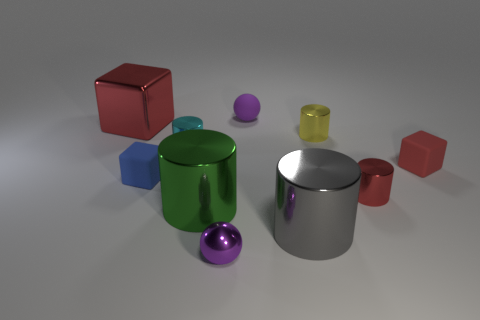What shape is the shiny thing that is the same color as the small matte ball?
Your answer should be compact. Sphere. How many metallic objects are either small purple spheres or big cyan spheres?
Give a very brief answer. 1. There is a big metal object that is behind the small metal cylinder on the left side of the green shiny cylinder; what is its shape?
Your response must be concise. Cube. Is the number of small cyan metallic objects that are on the right side of the big green object less than the number of large red blocks?
Ensure brevity in your answer.  Yes. The red matte thing has what shape?
Give a very brief answer. Cube. There is a red object left of the small purple metal object; how big is it?
Ensure brevity in your answer.  Large. What is the color of the shiny cube that is the same size as the green shiny object?
Ensure brevity in your answer.  Red. Are there any small matte things that have the same color as the small metal ball?
Provide a succinct answer. Yes. Are there fewer small yellow metallic cylinders behind the tiny purple matte object than purple spheres behind the small blue matte block?
Your answer should be compact. Yes. There is a red thing that is both on the right side of the small purple rubber ball and behind the small red cylinder; what is its material?
Give a very brief answer. Rubber. 